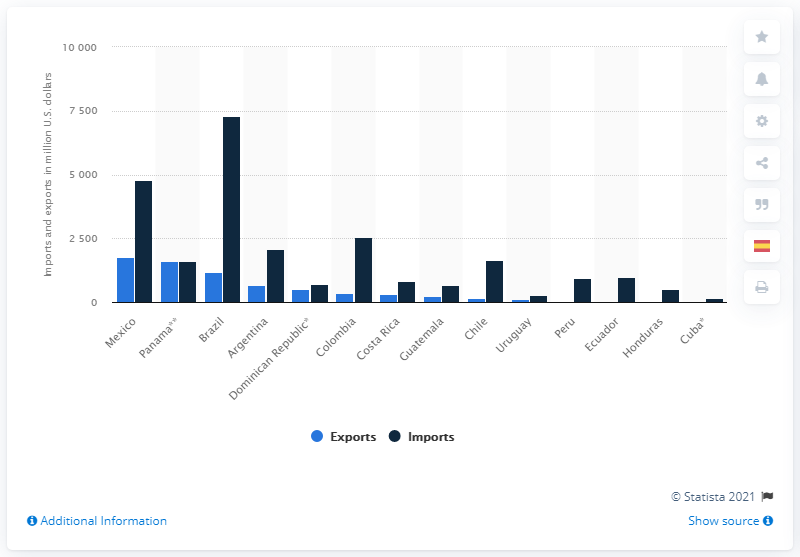Highlight a few significant elements in this photo. Brazil had the highest value of pharmaceutical imports in 2019. In 2019, Mexico had the highest value of pharmaceutical exports among all countries. 